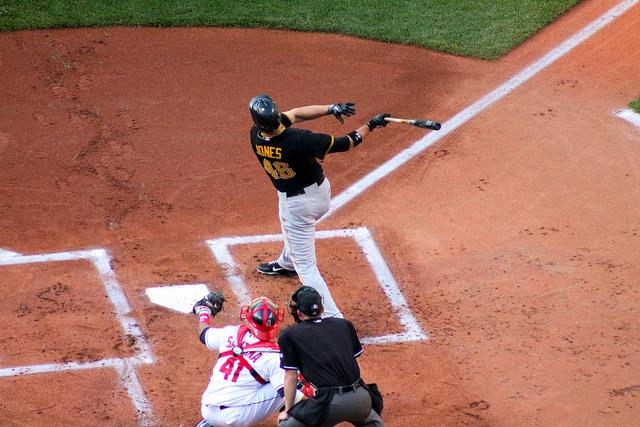What will the standing player do next? Please explain your reasoning. run. A baseball player has just swung the bat at a ball. 